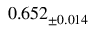Convert formula to latex. <formula><loc_0><loc_0><loc_500><loc_500>0 . 6 5 2 _ { \pm 0 . 0 1 4 }</formula> 